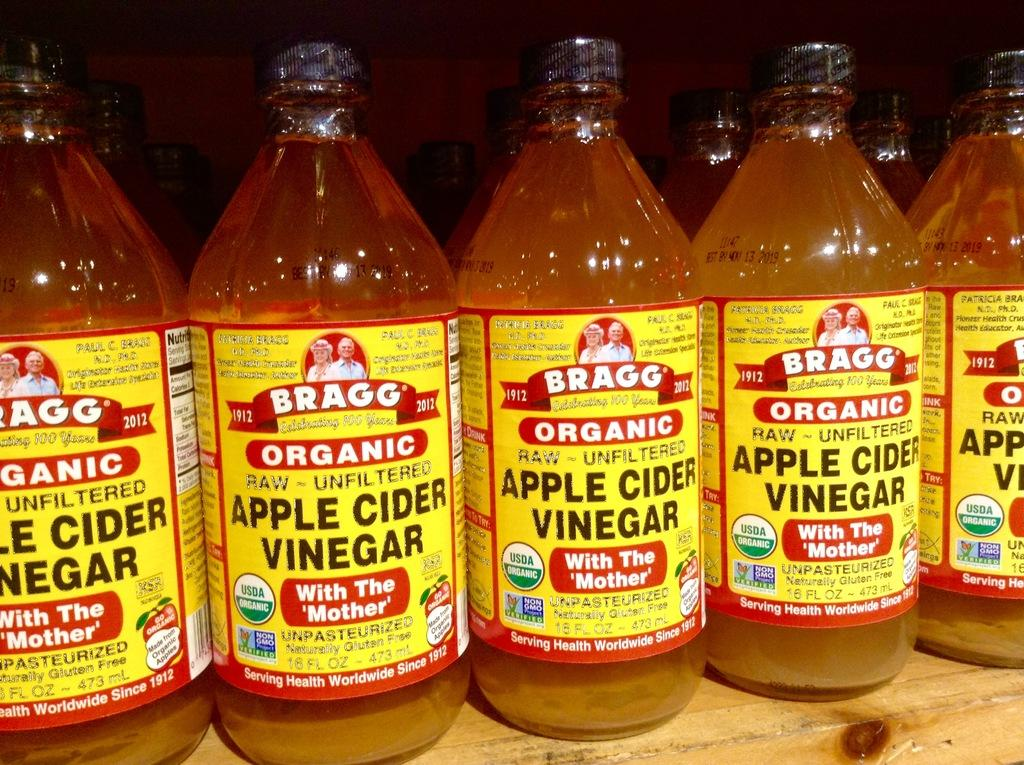Provide a one-sentence caption for the provided image. Several containers of Apple Cider Vinegar with yellow labels lined up on a shelf. 